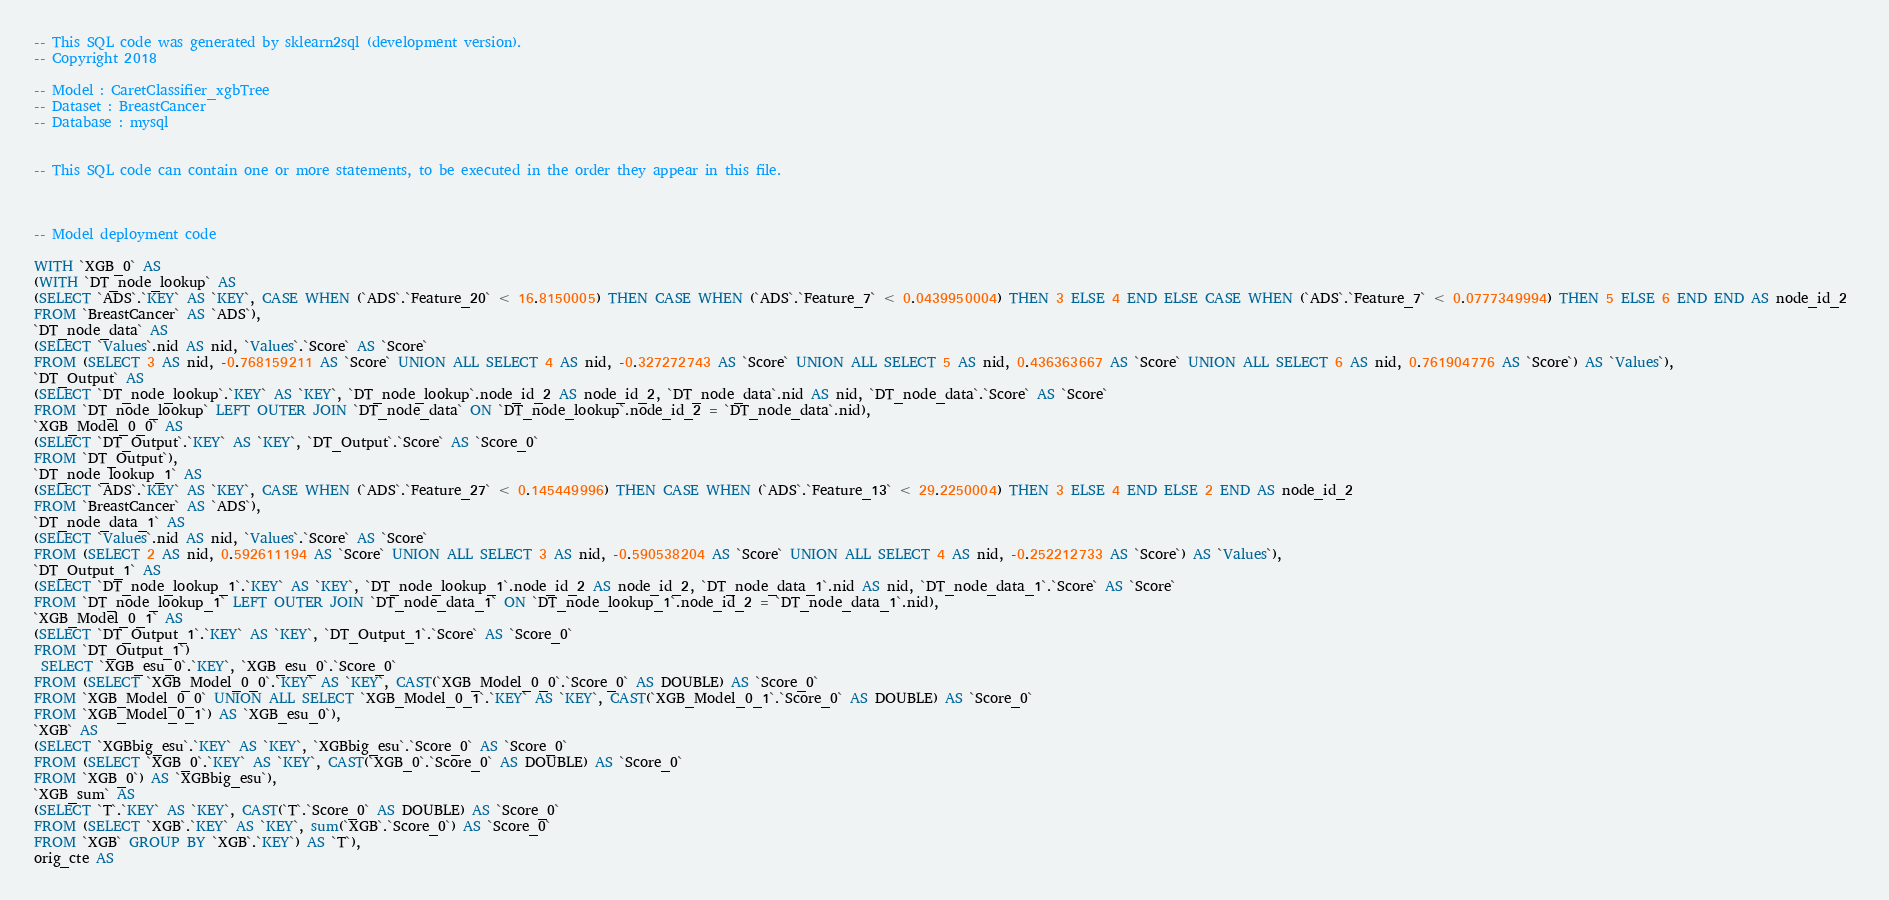<code> <loc_0><loc_0><loc_500><loc_500><_SQL_>-- This SQL code was generated by sklearn2sql (development version).
-- Copyright 2018

-- Model : CaretClassifier_xgbTree
-- Dataset : BreastCancer
-- Database : mysql


-- This SQL code can contain one or more statements, to be executed in the order they appear in this file.



-- Model deployment code

WITH `XGB_0` AS 
(WITH `DT_node_lookup` AS 
(SELECT `ADS`.`KEY` AS `KEY`, CASE WHEN (`ADS`.`Feature_20` < 16.8150005) THEN CASE WHEN (`ADS`.`Feature_7` < 0.0439950004) THEN 3 ELSE 4 END ELSE CASE WHEN (`ADS`.`Feature_7` < 0.0777349994) THEN 5 ELSE 6 END END AS node_id_2 
FROM `BreastCancer` AS `ADS`), 
`DT_node_data` AS 
(SELECT `Values`.nid AS nid, `Values`.`Score` AS `Score` 
FROM (SELECT 3 AS nid, -0.768159211 AS `Score` UNION ALL SELECT 4 AS nid, -0.327272743 AS `Score` UNION ALL SELECT 5 AS nid, 0.436363667 AS `Score` UNION ALL SELECT 6 AS nid, 0.761904776 AS `Score`) AS `Values`), 
`DT_Output` AS 
(SELECT `DT_node_lookup`.`KEY` AS `KEY`, `DT_node_lookup`.node_id_2 AS node_id_2, `DT_node_data`.nid AS nid, `DT_node_data`.`Score` AS `Score` 
FROM `DT_node_lookup` LEFT OUTER JOIN `DT_node_data` ON `DT_node_lookup`.node_id_2 = `DT_node_data`.nid), 
`XGB_Model_0_0` AS 
(SELECT `DT_Output`.`KEY` AS `KEY`, `DT_Output`.`Score` AS `Score_0` 
FROM `DT_Output`), 
`DT_node_lookup_1` AS 
(SELECT `ADS`.`KEY` AS `KEY`, CASE WHEN (`ADS`.`Feature_27` < 0.145449996) THEN CASE WHEN (`ADS`.`Feature_13` < 29.2250004) THEN 3 ELSE 4 END ELSE 2 END AS node_id_2 
FROM `BreastCancer` AS `ADS`), 
`DT_node_data_1` AS 
(SELECT `Values`.nid AS nid, `Values`.`Score` AS `Score` 
FROM (SELECT 2 AS nid, 0.592611194 AS `Score` UNION ALL SELECT 3 AS nid, -0.590538204 AS `Score` UNION ALL SELECT 4 AS nid, -0.252212733 AS `Score`) AS `Values`), 
`DT_Output_1` AS 
(SELECT `DT_node_lookup_1`.`KEY` AS `KEY`, `DT_node_lookup_1`.node_id_2 AS node_id_2, `DT_node_data_1`.nid AS nid, `DT_node_data_1`.`Score` AS `Score` 
FROM `DT_node_lookup_1` LEFT OUTER JOIN `DT_node_data_1` ON `DT_node_lookup_1`.node_id_2 = `DT_node_data_1`.nid), 
`XGB_Model_0_1` AS 
(SELECT `DT_Output_1`.`KEY` AS `KEY`, `DT_Output_1`.`Score` AS `Score_0` 
FROM `DT_Output_1`)
 SELECT `XGB_esu_0`.`KEY`, `XGB_esu_0`.`Score_0` 
FROM (SELECT `XGB_Model_0_0`.`KEY` AS `KEY`, CAST(`XGB_Model_0_0`.`Score_0` AS DOUBLE) AS `Score_0` 
FROM `XGB_Model_0_0` UNION ALL SELECT `XGB_Model_0_1`.`KEY` AS `KEY`, CAST(`XGB_Model_0_1`.`Score_0` AS DOUBLE) AS `Score_0` 
FROM `XGB_Model_0_1`) AS `XGB_esu_0`), 
`XGB` AS 
(SELECT `XGBbig_esu`.`KEY` AS `KEY`, `XGBbig_esu`.`Score_0` AS `Score_0` 
FROM (SELECT `XGB_0`.`KEY` AS `KEY`, CAST(`XGB_0`.`Score_0` AS DOUBLE) AS `Score_0` 
FROM `XGB_0`) AS `XGBbig_esu`), 
`XGB_sum` AS 
(SELECT `T`.`KEY` AS `KEY`, CAST(`T`.`Score_0` AS DOUBLE) AS `Score_0` 
FROM (SELECT `XGB`.`KEY` AS `KEY`, sum(`XGB`.`Score_0`) AS `Score_0` 
FROM `XGB` GROUP BY `XGB`.`KEY`) AS `T`), 
orig_cte AS </code> 